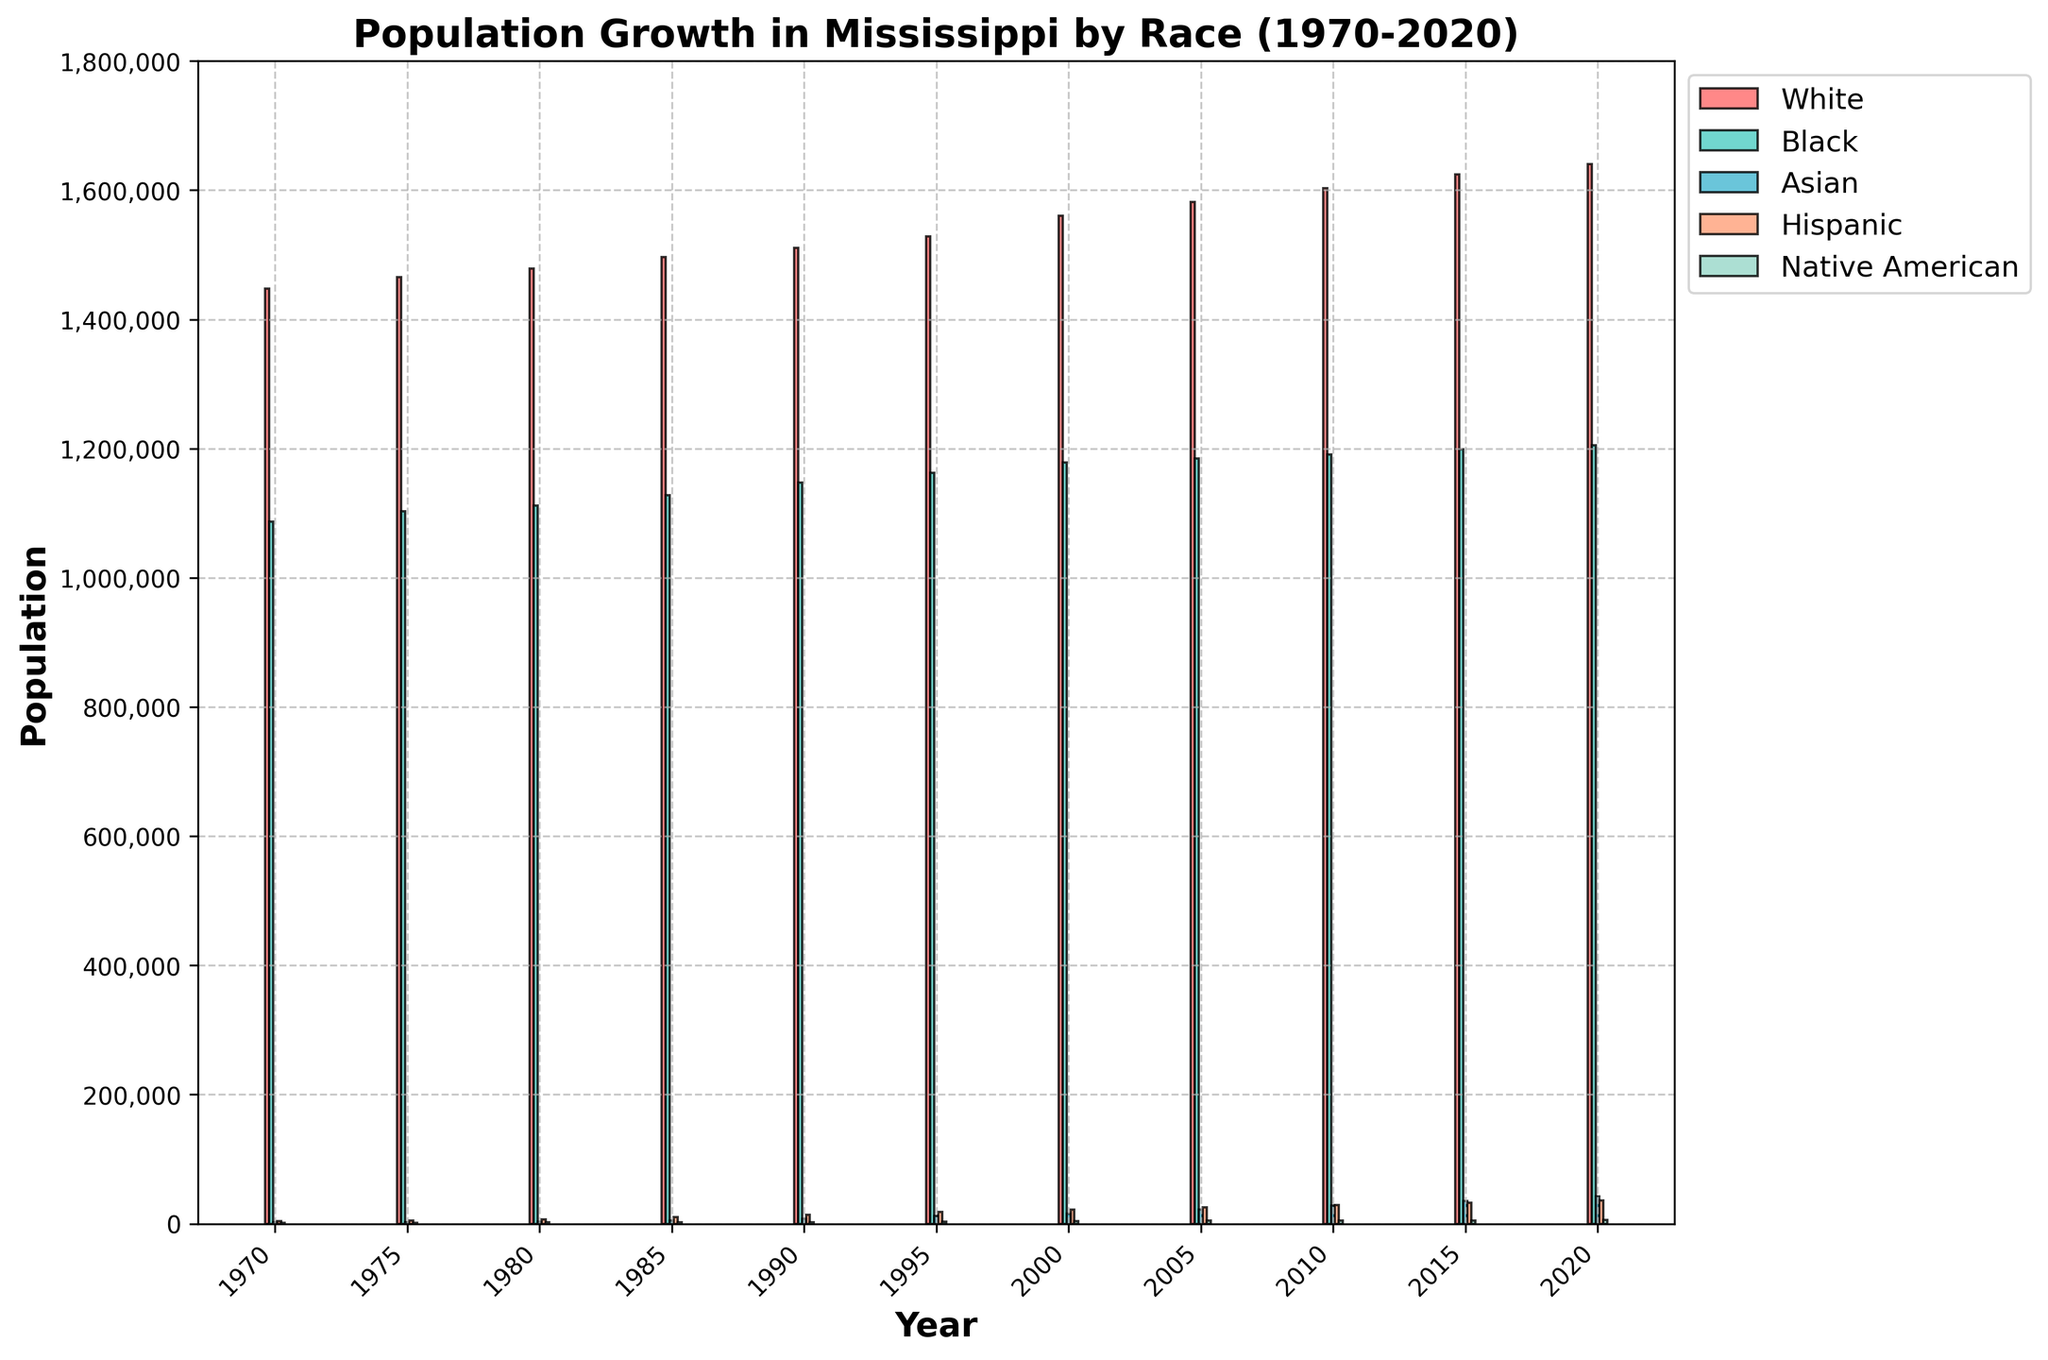What is the title of the plot? The title of the plot is usually found at the top-center, often in a larger font size compared to other text on the plot. Here, it is located at the top of the figure, indicating the subject of the plot.
Answer: Population Growth in Mississippi by Race (1970-2020) What is the population of the Native American demographic in the year 2000? Locate the year 2000 on the x-axis and find the height of the bar corresponding to the Native American label. Each bar color represents a different racial group, with the color code for Native American specified in the code snippet.
Answer: 4000 Among the racial demographics listed, which had the highest population growth between 1970 and 2020? Calculate the difference in population for each racial group between 2020 and 1970, then compare these growth values. By visually inspecting the height differences of the bars over these years, we see the biggest increase for the White demographic.
Answer: White How did the Asian demographic's population change from 1975 to 1985? Observe the height of the bars for the Asian demographic in the years 1975 and 1985, and calculate the difference between them.
Answer: Increased by 2500 (from 2500 to 5000) Which year had the smallest total population across all demographics listed? For each year on the x-axis, sum the heights of the bars (representing different demographics) and compare these sums. The year with the smallest total will have the shortest cumulative height.
Answer: 1970 What is the trend of the Hispanic demographic’s population from 1970 to 2020? Observe the change in height for the Hispanic demographic bars from 1970 to 2020. Notice that the height of each bar steadily increases over the years.
Answer: Increasing How does the population of the Black demographic in 1990 compare to that in 2000? Find the bars corresponding to the Black demographic in 1990 and 2000, observe their heights, and compare.
Answer: Increased from 1147000 to 1178400 What are the colors representing the Asian and Hispanic demographics? Look at the legend on the plot; each demographic is assigned a specific color which is shown next to the demographic name.
Answer: Light blue for Asian and Light pink for Hispanic Between which consecutive years did the Hispanic demographic experience the most significant growth? Compare the differences in the height of the Hispanic demographic bars between each pair of consecutive years. The largest height difference indicates the most significant growth period.
Answer: 1985 to 1990 Which demographic shows the least variation in population over the 50 years? Examine the height of the bars for each demographic over all years and identify the demographic with the smallest differences in bar heights over time.
Answer: Native American 